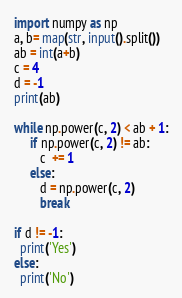Convert code to text. <code><loc_0><loc_0><loc_500><loc_500><_Python_>import numpy as np
a, b= map(str, input().split())
ab = int(a+b)
c = 4
d = -1
print(ab)

while np.power(c, 2) < ab + 1:
     if np.power(c, 2) != ab:
        c  += 1
     else:
        d = np.power(c, 2) 
        break

if d != -1:
  print('Yes')
else:
  print('No')</code> 